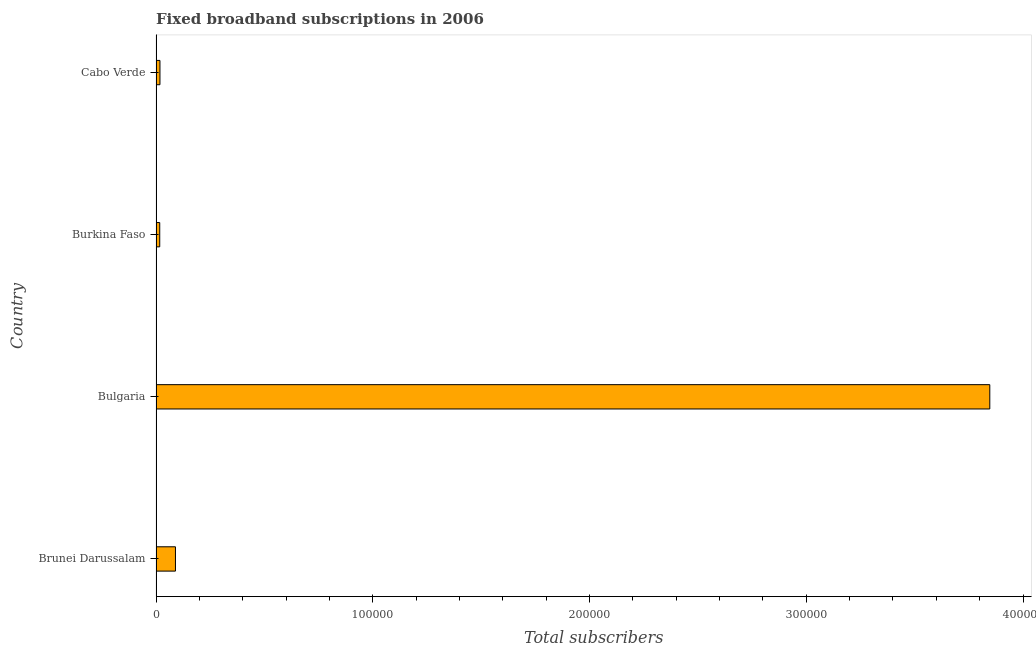Does the graph contain any zero values?
Offer a terse response. No. Does the graph contain grids?
Your response must be concise. No. What is the title of the graph?
Keep it short and to the point. Fixed broadband subscriptions in 2006. What is the label or title of the X-axis?
Provide a short and direct response. Total subscribers. What is the total number of fixed broadband subscriptions in Bulgaria?
Your response must be concise. 3.85e+05. Across all countries, what is the maximum total number of fixed broadband subscriptions?
Make the answer very short. 3.85e+05. Across all countries, what is the minimum total number of fixed broadband subscriptions?
Your response must be concise. 1715. In which country was the total number of fixed broadband subscriptions minimum?
Provide a short and direct response. Burkina Faso. What is the sum of the total number of fixed broadband subscriptions?
Give a very brief answer. 3.97e+05. What is the difference between the total number of fixed broadband subscriptions in Bulgaria and Burkina Faso?
Offer a very short reply. 3.83e+05. What is the average total number of fixed broadband subscriptions per country?
Make the answer very short. 9.93e+04. What is the median total number of fixed broadband subscriptions?
Give a very brief answer. 5389. In how many countries, is the total number of fixed broadband subscriptions greater than 160000 ?
Offer a very short reply. 1. What is the ratio of the total number of fixed broadband subscriptions in Brunei Darussalam to that in Bulgaria?
Ensure brevity in your answer.  0.02. Is the difference between the total number of fixed broadband subscriptions in Bulgaria and Burkina Faso greater than the difference between any two countries?
Your answer should be compact. Yes. What is the difference between the highest and the second highest total number of fixed broadband subscriptions?
Provide a short and direct response. 3.76e+05. What is the difference between the highest and the lowest total number of fixed broadband subscriptions?
Provide a short and direct response. 3.83e+05. How many countries are there in the graph?
Provide a succinct answer. 4. What is the difference between two consecutive major ticks on the X-axis?
Ensure brevity in your answer.  1.00e+05. Are the values on the major ticks of X-axis written in scientific E-notation?
Your answer should be compact. No. What is the Total subscribers in Brunei Darussalam?
Offer a terse response. 8964. What is the Total subscribers in Bulgaria?
Offer a terse response. 3.85e+05. What is the Total subscribers of Burkina Faso?
Provide a succinct answer. 1715. What is the Total subscribers of Cabo Verde?
Provide a short and direct response. 1814. What is the difference between the Total subscribers in Brunei Darussalam and Bulgaria?
Make the answer very short. -3.76e+05. What is the difference between the Total subscribers in Brunei Darussalam and Burkina Faso?
Ensure brevity in your answer.  7249. What is the difference between the Total subscribers in Brunei Darussalam and Cabo Verde?
Your response must be concise. 7150. What is the difference between the Total subscribers in Bulgaria and Burkina Faso?
Offer a terse response. 3.83e+05. What is the difference between the Total subscribers in Bulgaria and Cabo Verde?
Keep it short and to the point. 3.83e+05. What is the difference between the Total subscribers in Burkina Faso and Cabo Verde?
Ensure brevity in your answer.  -99. What is the ratio of the Total subscribers in Brunei Darussalam to that in Bulgaria?
Give a very brief answer. 0.02. What is the ratio of the Total subscribers in Brunei Darussalam to that in Burkina Faso?
Offer a very short reply. 5.23. What is the ratio of the Total subscribers in Brunei Darussalam to that in Cabo Verde?
Offer a very short reply. 4.94. What is the ratio of the Total subscribers in Bulgaria to that in Burkina Faso?
Provide a succinct answer. 224.3. What is the ratio of the Total subscribers in Bulgaria to that in Cabo Verde?
Offer a terse response. 212.06. What is the ratio of the Total subscribers in Burkina Faso to that in Cabo Verde?
Offer a terse response. 0.94. 